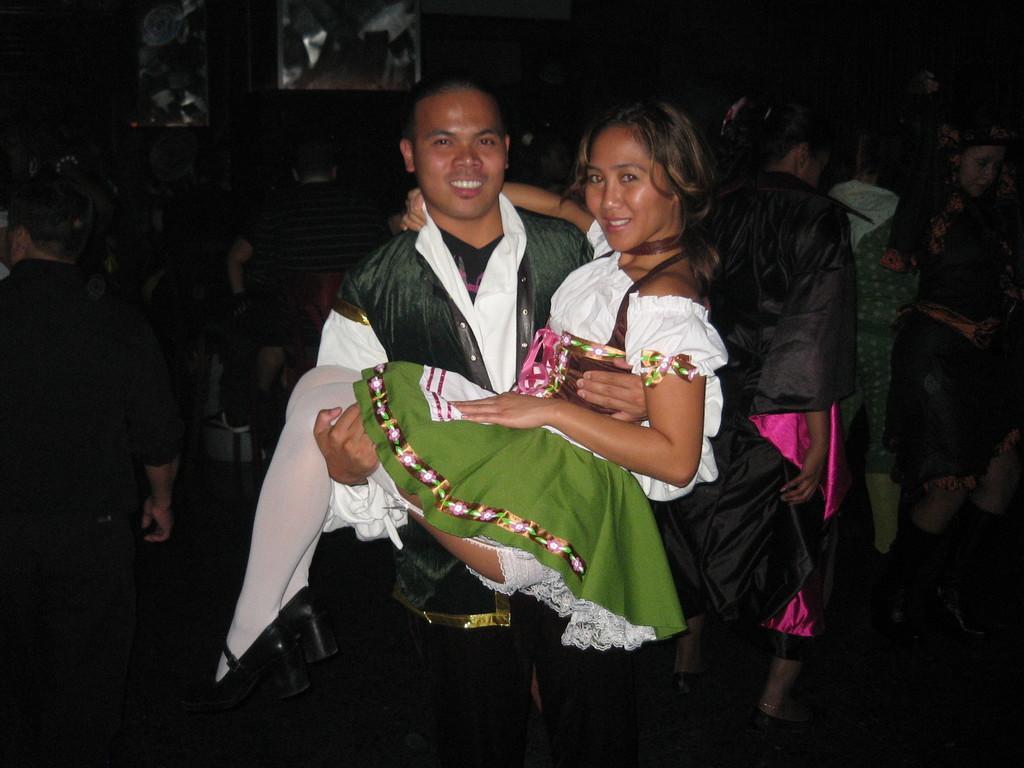Describe this image in one or two sentences. This man is lifting a girl. Background there are people. 